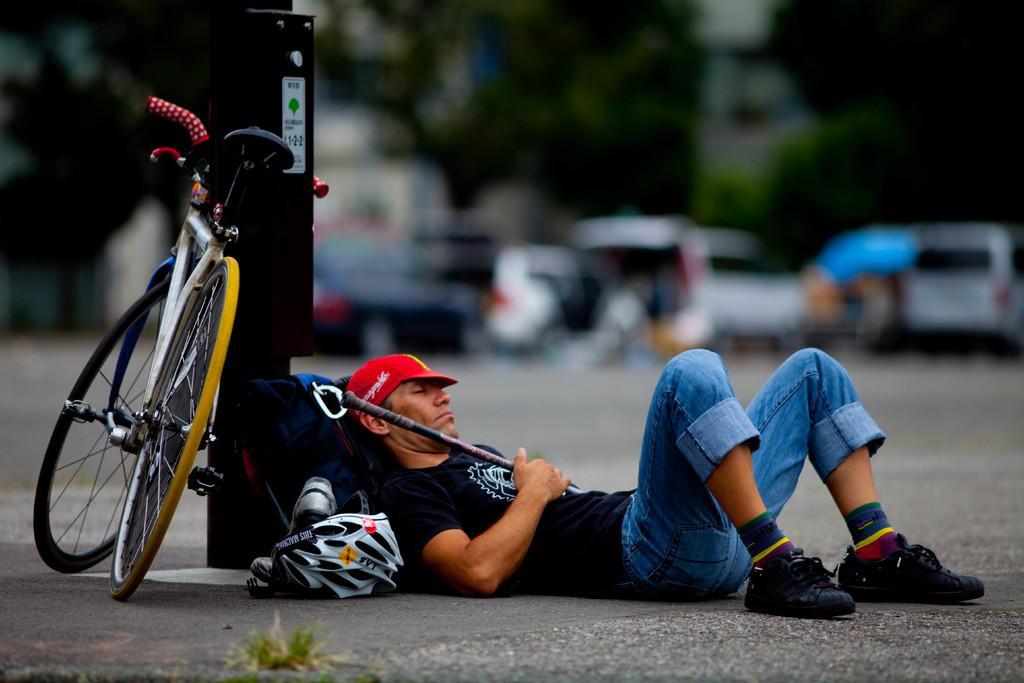Describe this image in one or two sentences. In this picture we can see a bicycle, helmet and a man lying on the road and in the background we can see vehicles, trees and it is blurry. 